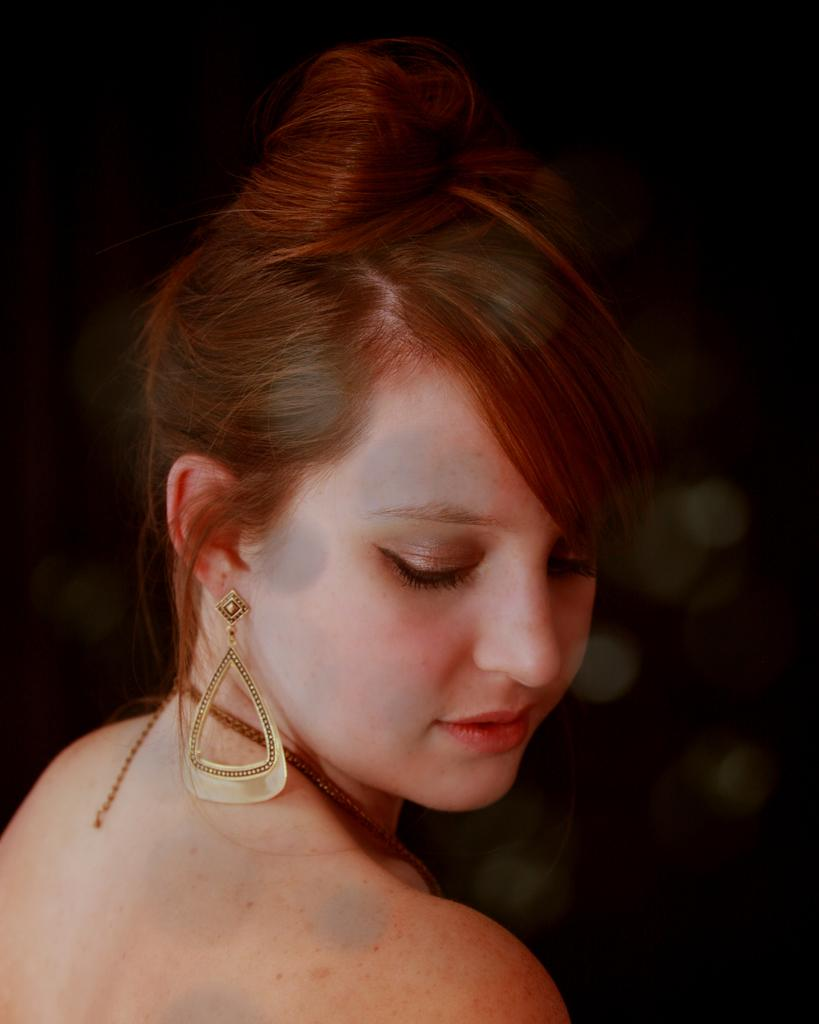Who is the main subject in the image? There is a lady in the image. What can be observed about the background of the image? The background of the image is dark. What type of watch is the fireman wearing in the image? There is no fireman or watch present in the image; it only features a lady. What metal objects can be seen in the image? There is no mention of any metal objects in the provided facts, so we cannot determine if any are present in the image. 